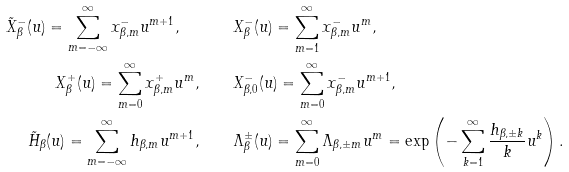Convert formula to latex. <formula><loc_0><loc_0><loc_500><loc_500>\tilde { X } _ { \beta } ^ { - } ( u ) = \sum _ { m = - \infty } ^ { \infty } x _ { \beta , m } ^ { - } u ^ { m + 1 } , \quad & \quad X _ { \beta } ^ { - } ( u ) = \sum _ { m = 1 } ^ { \infty } x _ { \beta , m } ^ { - } u ^ { m } , \\ X _ { \beta } ^ { + } ( u ) = \sum _ { m = 0 } ^ { \infty } x _ { \beta , m } ^ { + } u ^ { m } , \quad & \quad X _ { \beta , 0 } ^ { - } ( u ) = \sum _ { m = 0 } ^ { \infty } x _ { \beta , m } ^ { - } u ^ { m + 1 } , \\ \tilde { H } _ { \beta } ( u ) = \sum _ { m = - \infty } ^ { \infty } h _ { \beta , m } u ^ { m + 1 } , \quad & \quad \Lambda _ { \beta } ^ { \pm } ( u ) = \sum _ { m = 0 } ^ { \infty } \Lambda _ { \beta , \pm m } u ^ { m } = { \text {exp} } \left ( - \sum _ { k = 1 } ^ { \infty } \frac { h _ { \beta , \pm k } } { k } u ^ { k } \right ) .</formula> 